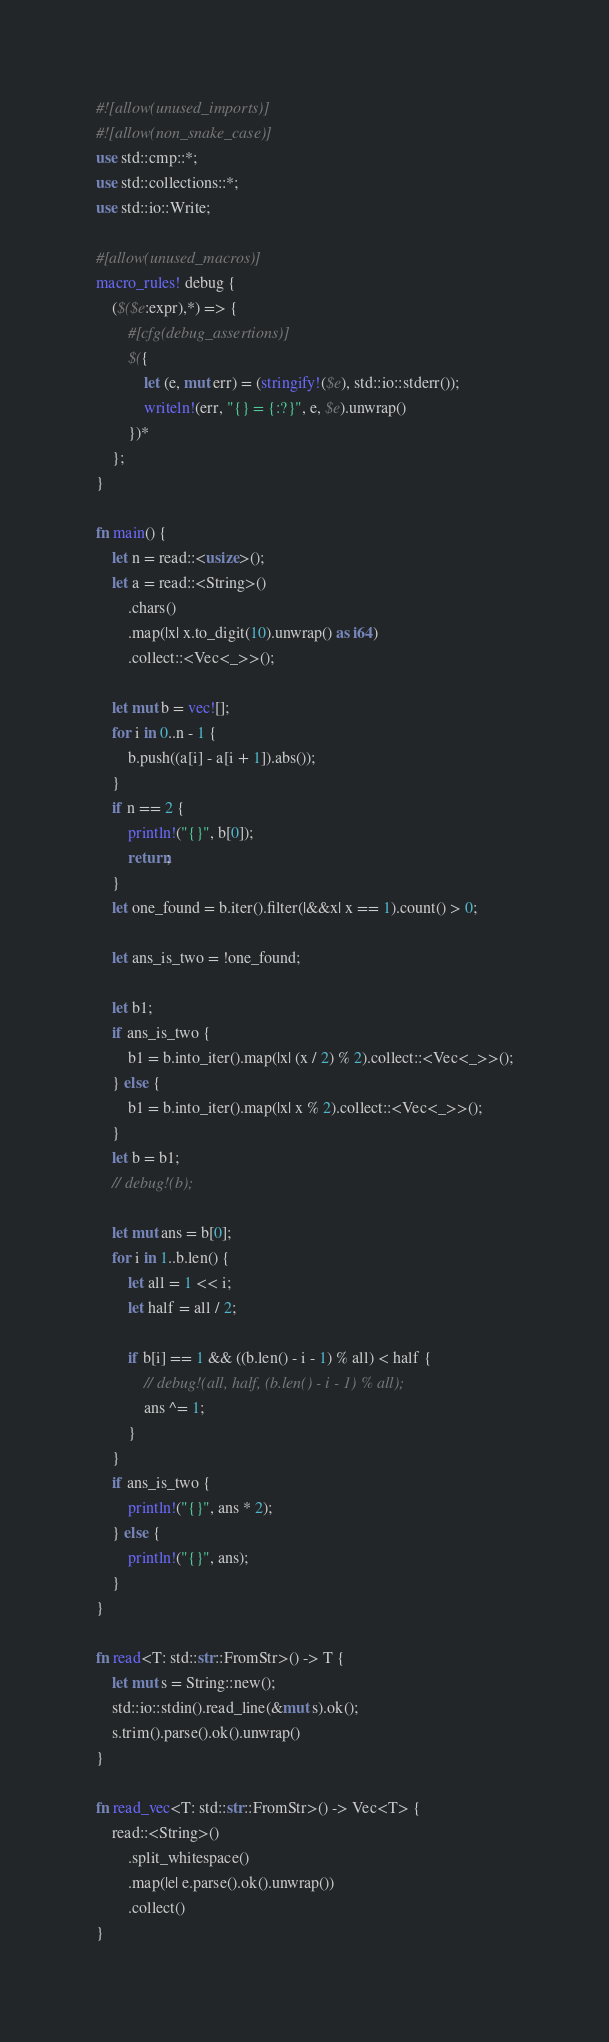<code> <loc_0><loc_0><loc_500><loc_500><_Rust_>#![allow(unused_imports)]
#![allow(non_snake_case)]
use std::cmp::*;
use std::collections::*;
use std::io::Write;

#[allow(unused_macros)]
macro_rules! debug {
    ($($e:expr),*) => {
        #[cfg(debug_assertions)]
        $({
            let (e, mut err) = (stringify!($e), std::io::stderr());
            writeln!(err, "{} = {:?}", e, $e).unwrap()
        })*
    };
}

fn main() {
    let n = read::<usize>();
    let a = read::<String>()
        .chars()
        .map(|x| x.to_digit(10).unwrap() as i64)
        .collect::<Vec<_>>();

    let mut b = vec![];
    for i in 0..n - 1 {
        b.push((a[i] - a[i + 1]).abs());
    }
    if n == 2 {
        println!("{}", b[0]);
        return;
    }
    let one_found = b.iter().filter(|&&x| x == 1).count() > 0;

    let ans_is_two = !one_found;

    let b1;
    if ans_is_two {
        b1 = b.into_iter().map(|x| (x / 2) % 2).collect::<Vec<_>>();
    } else {
        b1 = b.into_iter().map(|x| x % 2).collect::<Vec<_>>();
    }
    let b = b1;
    // debug!(b);

    let mut ans = b[0];
    for i in 1..b.len() {
        let all = 1 << i;
        let half = all / 2;

        if b[i] == 1 && ((b.len() - i - 1) % all) < half {
            // debug!(all, half, (b.len() - i - 1) % all);
            ans ^= 1;
        }
    }
    if ans_is_two {
        println!("{}", ans * 2);
    } else {
        println!("{}", ans);
    }
}

fn read<T: std::str::FromStr>() -> T {
    let mut s = String::new();
    std::io::stdin().read_line(&mut s).ok();
    s.trim().parse().ok().unwrap()
}

fn read_vec<T: std::str::FromStr>() -> Vec<T> {
    read::<String>()
        .split_whitespace()
        .map(|e| e.parse().ok().unwrap())
        .collect()
}
</code> 